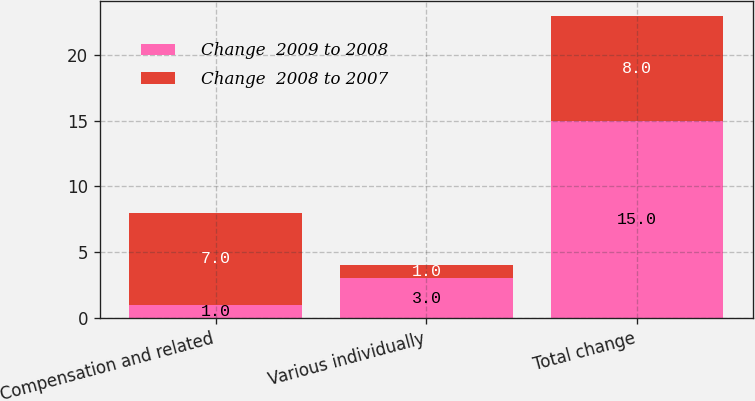<chart> <loc_0><loc_0><loc_500><loc_500><stacked_bar_chart><ecel><fcel>Compensation and related<fcel>Various individually<fcel>Total change<nl><fcel>Change  2009 to 2008<fcel>1<fcel>3<fcel>15<nl><fcel>Change  2008 to 2007<fcel>7<fcel>1<fcel>8<nl></chart> 